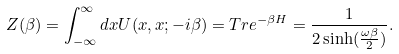<formula> <loc_0><loc_0><loc_500><loc_500>Z ( \beta ) = \int _ { - \infty } ^ { \infty } d x U ( x , x ; - i \beta ) = T r e ^ { - \beta H } = \frac { 1 } { 2 \sinh ( \frac { \omega \beta } { 2 } ) } .</formula> 